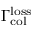Convert formula to latex. <formula><loc_0><loc_0><loc_500><loc_500>\Gamma _ { c o l } ^ { l o s s }</formula> 